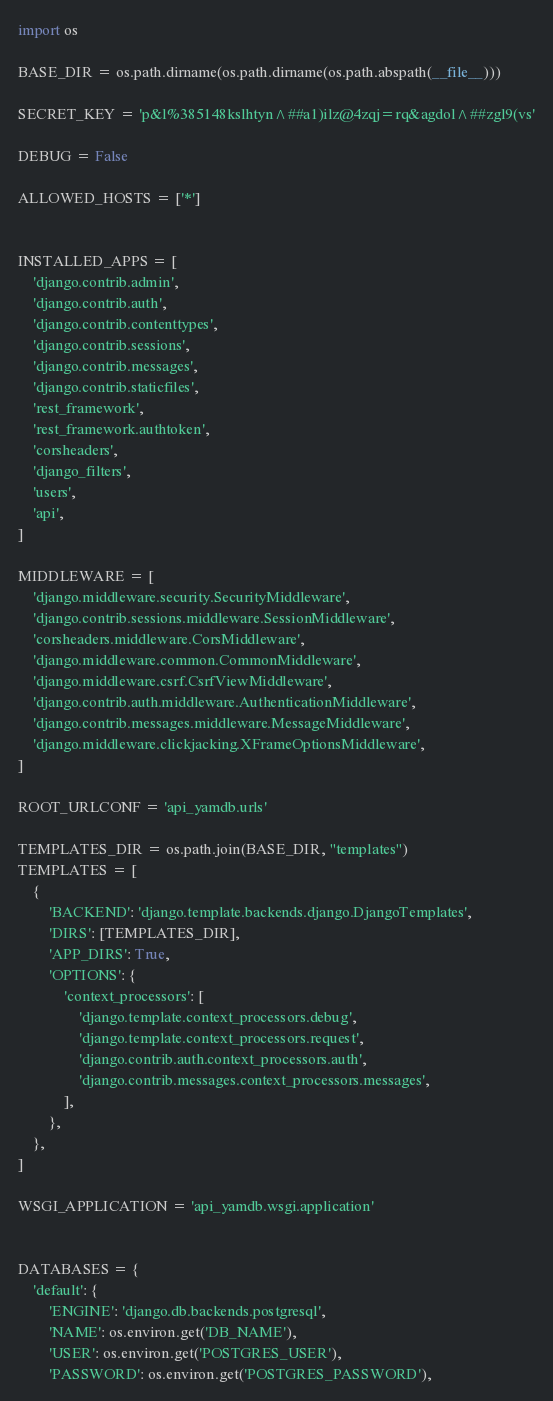<code> <loc_0><loc_0><loc_500><loc_500><_Python_>import os

BASE_DIR = os.path.dirname(os.path.dirname(os.path.abspath(__file__)))

SECRET_KEY = 'p&l%385148kslhtyn^##a1)ilz@4zqj=rq&agdol^##zgl9(vs'

DEBUG = False

ALLOWED_HOSTS = ['*']


INSTALLED_APPS = [
    'django.contrib.admin',
    'django.contrib.auth',
    'django.contrib.contenttypes',
    'django.contrib.sessions',
    'django.contrib.messages',
    'django.contrib.staticfiles',
    'rest_framework',
    'rest_framework.authtoken',
    'corsheaders',
    'django_filters',
    'users',
    'api',
]

MIDDLEWARE = [
    'django.middleware.security.SecurityMiddleware',
    'django.contrib.sessions.middleware.SessionMiddleware',
    'corsheaders.middleware.CorsMiddleware',
    'django.middleware.common.CommonMiddleware',
    'django.middleware.csrf.CsrfViewMiddleware',
    'django.contrib.auth.middleware.AuthenticationMiddleware',
    'django.contrib.messages.middleware.MessageMiddleware',
    'django.middleware.clickjacking.XFrameOptionsMiddleware',
]

ROOT_URLCONF = 'api_yamdb.urls'

TEMPLATES_DIR = os.path.join(BASE_DIR, "templates")
TEMPLATES = [
    {
        'BACKEND': 'django.template.backends.django.DjangoTemplates',
        'DIRS': [TEMPLATES_DIR],
        'APP_DIRS': True,
        'OPTIONS': {
            'context_processors': [
                'django.template.context_processors.debug',
                'django.template.context_processors.request',
                'django.contrib.auth.context_processors.auth',
                'django.contrib.messages.context_processors.messages',
            ],
        },
    },
]

WSGI_APPLICATION = 'api_yamdb.wsgi.application'


DATABASES = {
    'default': {
        'ENGINE': 'django.db.backends.postgresql',
        'NAME': os.environ.get('DB_NAME'),
        'USER': os.environ.get('POSTGRES_USER'),
        'PASSWORD': os.environ.get('POSTGRES_PASSWORD'),</code> 